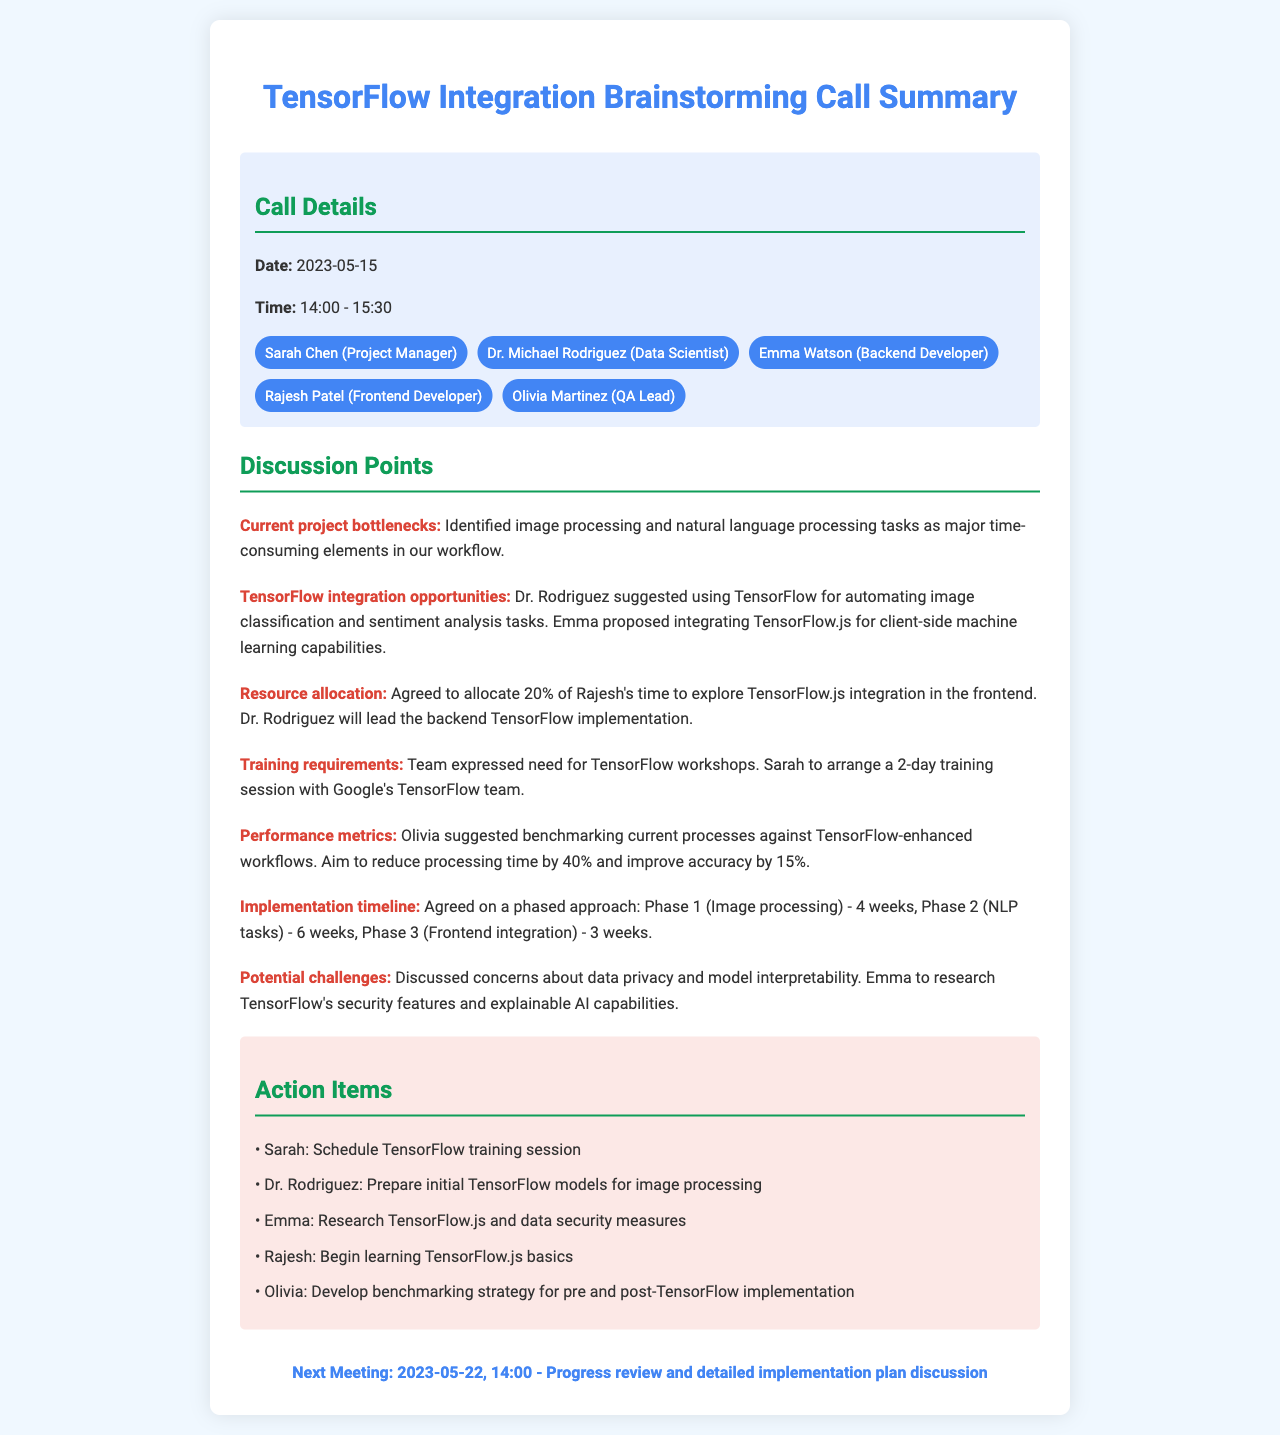what is the date of the call? The call took place on May 15, 2023.
Answer: May 15, 2023 who suggested using TensorFlow for automating image classification? Dr. Rodriguez made the suggestion for automating image classification tasks.
Answer: Dr. Rodriguez how long is the implementation timeline for Phase 1? Phase 1 for image processing is scheduled to take 4 weeks according to the timeline.
Answer: 4 weeks what percentage of Rajesh's time is allocated to explore TensorFlow.js integration? Rajesh's time allocation for TensorFlow.js integration has been set at 20%.
Answer: 20% what is the goal for reducing processing time after TensorFlow integration? The team aims to reduce processing time by 40% after integrating TensorFlow.
Answer: 40% which team member is responsible for researching TensorFlow's security features? Emma is tasked with researching TensorFlow's security features.
Answer: Emma what is the date of the next meeting? The next meeting is scheduled for May 22, 2023.
Answer: May 22, 2023 who is leading the backend TensorFlow implementation? Dr. Rodriguez is responsible for leading the backend TensorFlow implementation.
Answer: Dr. Rodriguez how many action items are listed in the document? There are five action items provided in the call summary.
Answer: five 